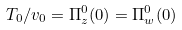<formula> <loc_0><loc_0><loc_500><loc_500>T _ { 0 } / v _ { 0 } = \Pi _ { z } ^ { 0 } ( 0 ) = \Pi _ { w } ^ { 0 } ( 0 )</formula> 